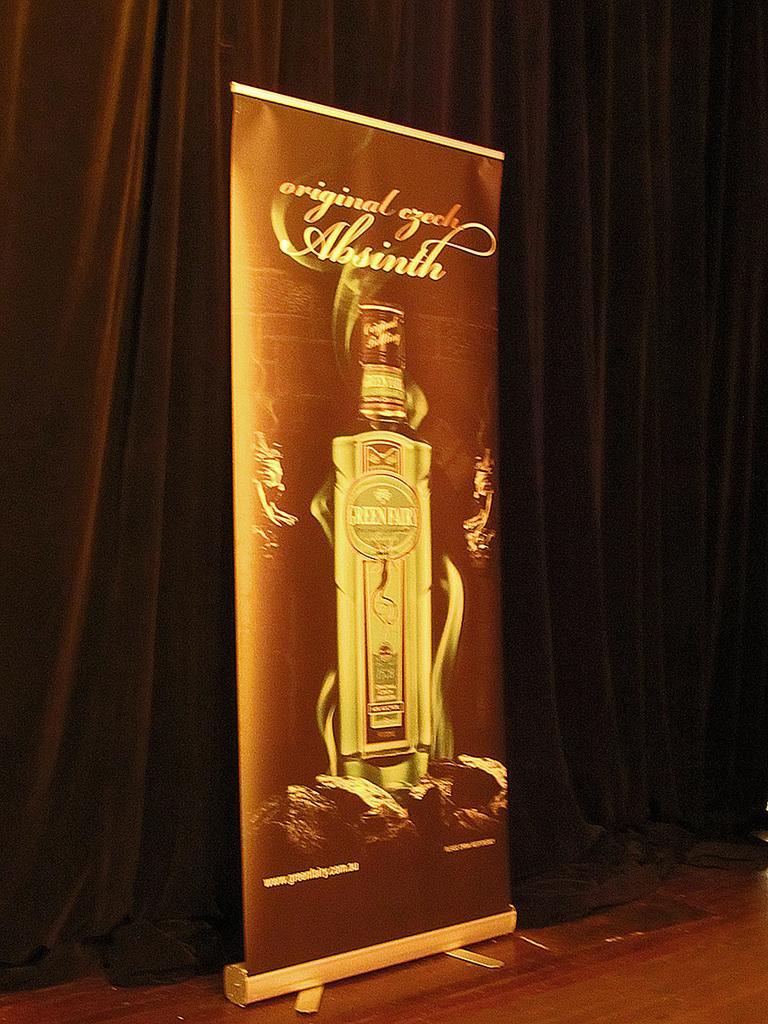What is the main object in the center of the image? There is a banner in the center of the image. What can be seen in the background of the image? There is a curtain in the background of the image. How many mice are hiding behind the curtain in the image? There are no mice present in the image; it only features a banner and a curtain. 